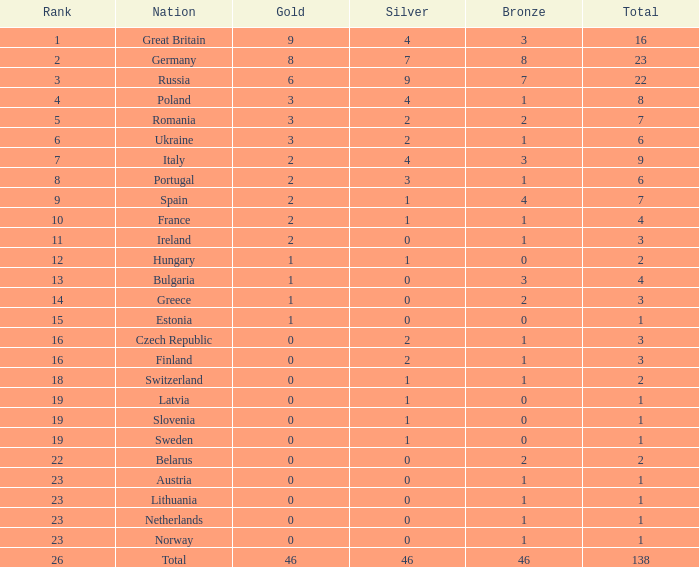What is the aggregate amount for a total when the country is the netherlands and silver is above 0? 0.0. 